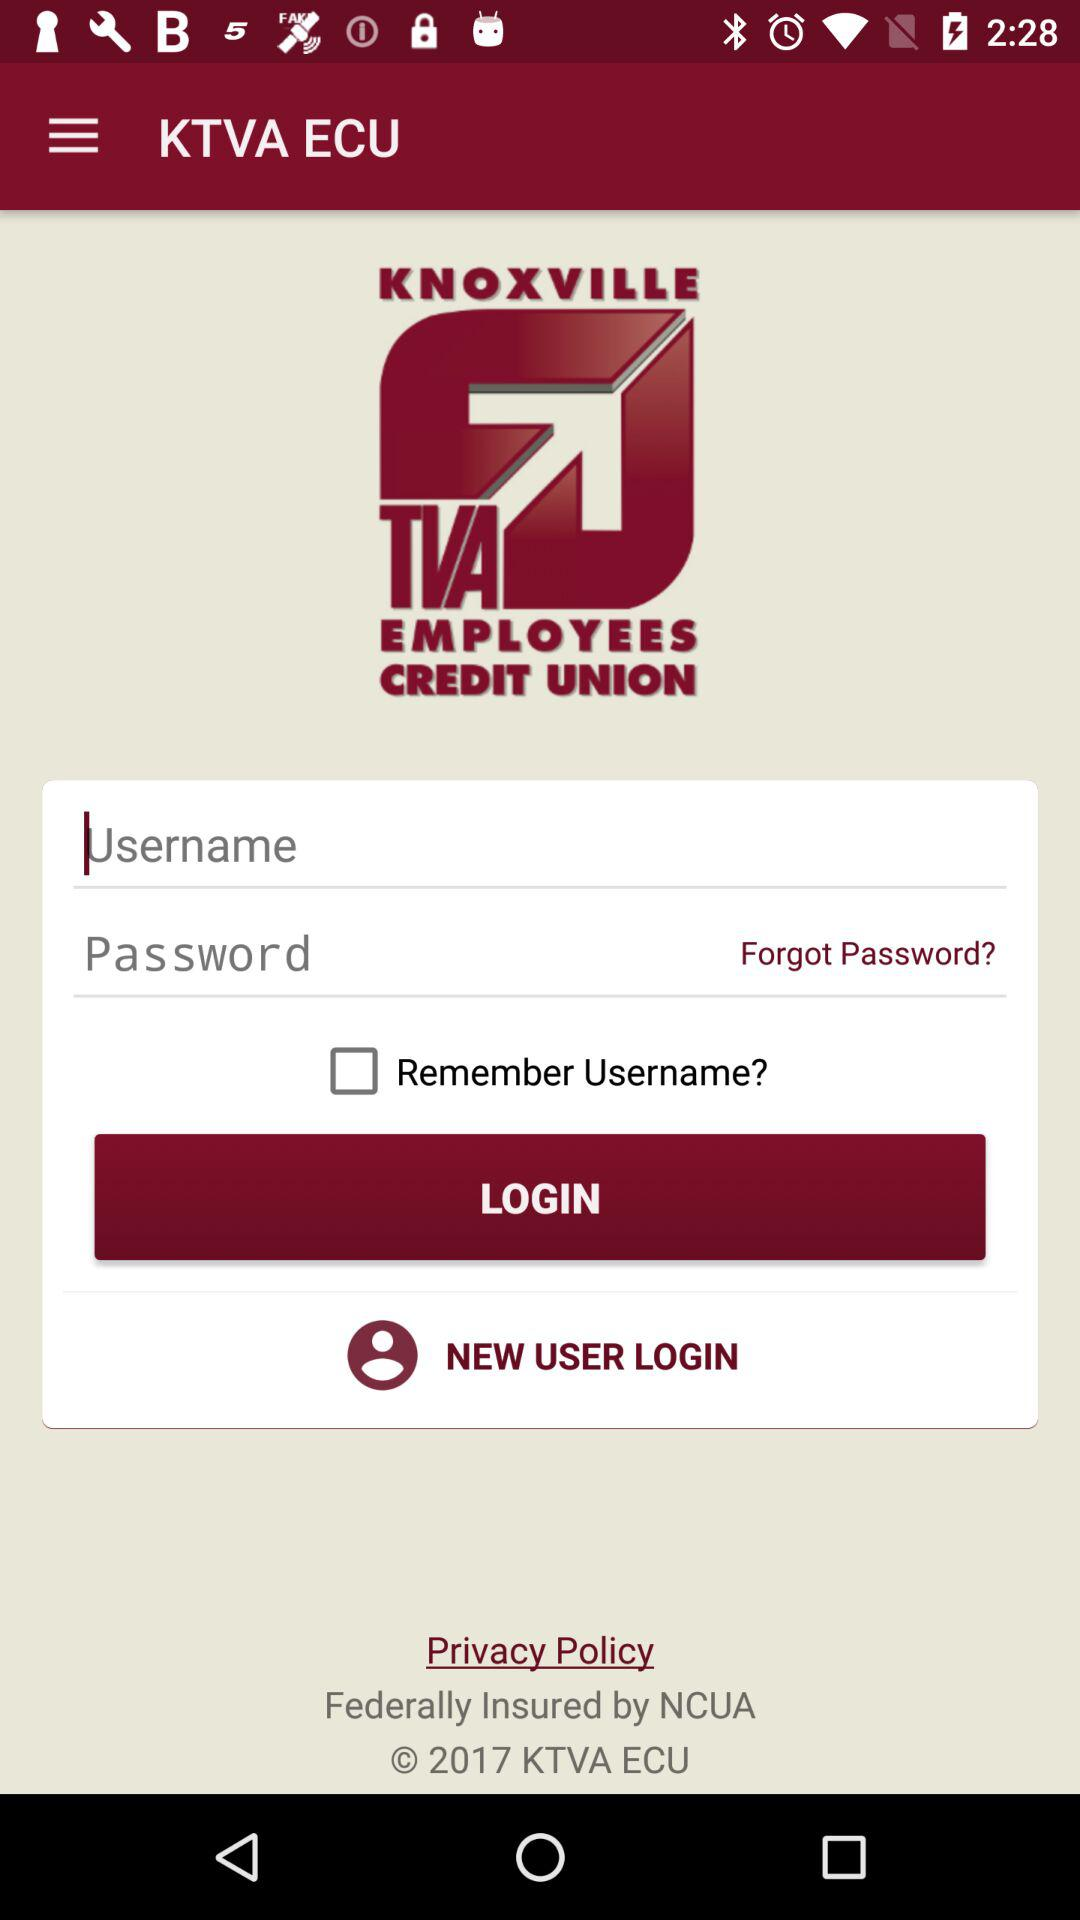How many text inputs are on the screen?
Answer the question using a single word or phrase. 2 